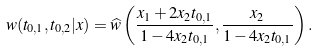<formula> <loc_0><loc_0><loc_500><loc_500>w ( t _ { 0 , 1 } , t _ { 0 , 2 } | x ) = \widehat { w } \left ( \frac { x _ { 1 } + 2 x _ { 2 } t _ { 0 , 1 } } { 1 - 4 x _ { 2 } t _ { 0 , 1 } } , \frac { x _ { 2 } } { 1 - 4 x _ { 2 } t _ { 0 , 1 } } \right ) .</formula> 